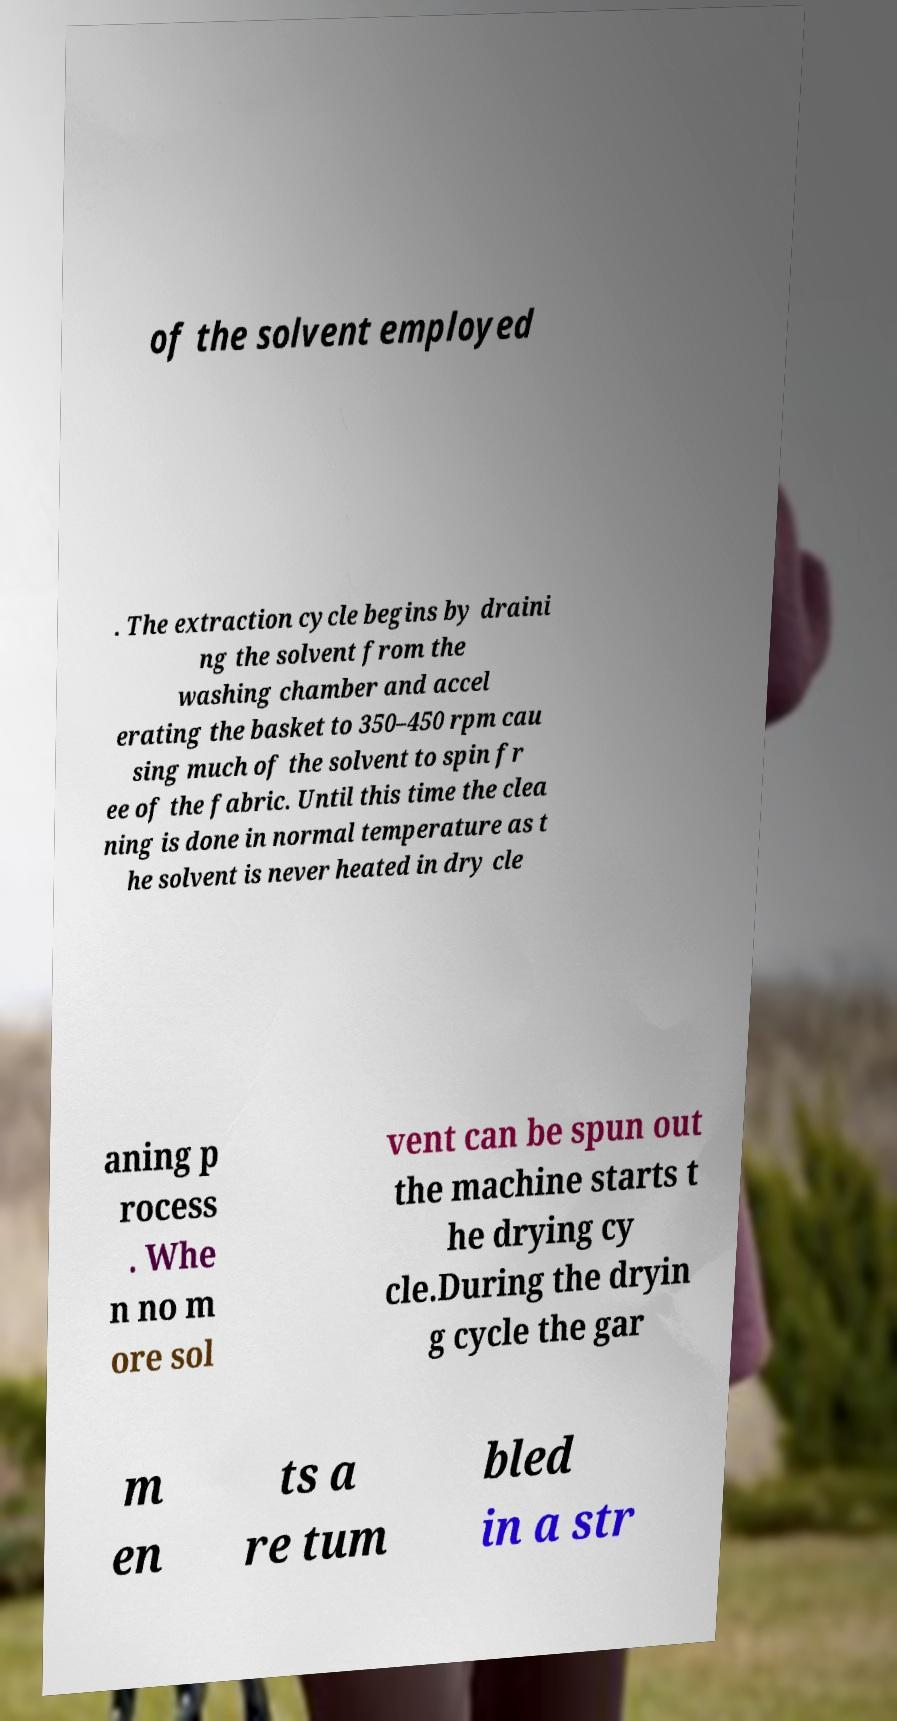Please identify and transcribe the text found in this image. of the solvent employed . The extraction cycle begins by draini ng the solvent from the washing chamber and accel erating the basket to 350–450 rpm cau sing much of the solvent to spin fr ee of the fabric. Until this time the clea ning is done in normal temperature as t he solvent is never heated in dry cle aning p rocess . Whe n no m ore sol vent can be spun out the machine starts t he drying cy cle.During the dryin g cycle the gar m en ts a re tum bled in a str 